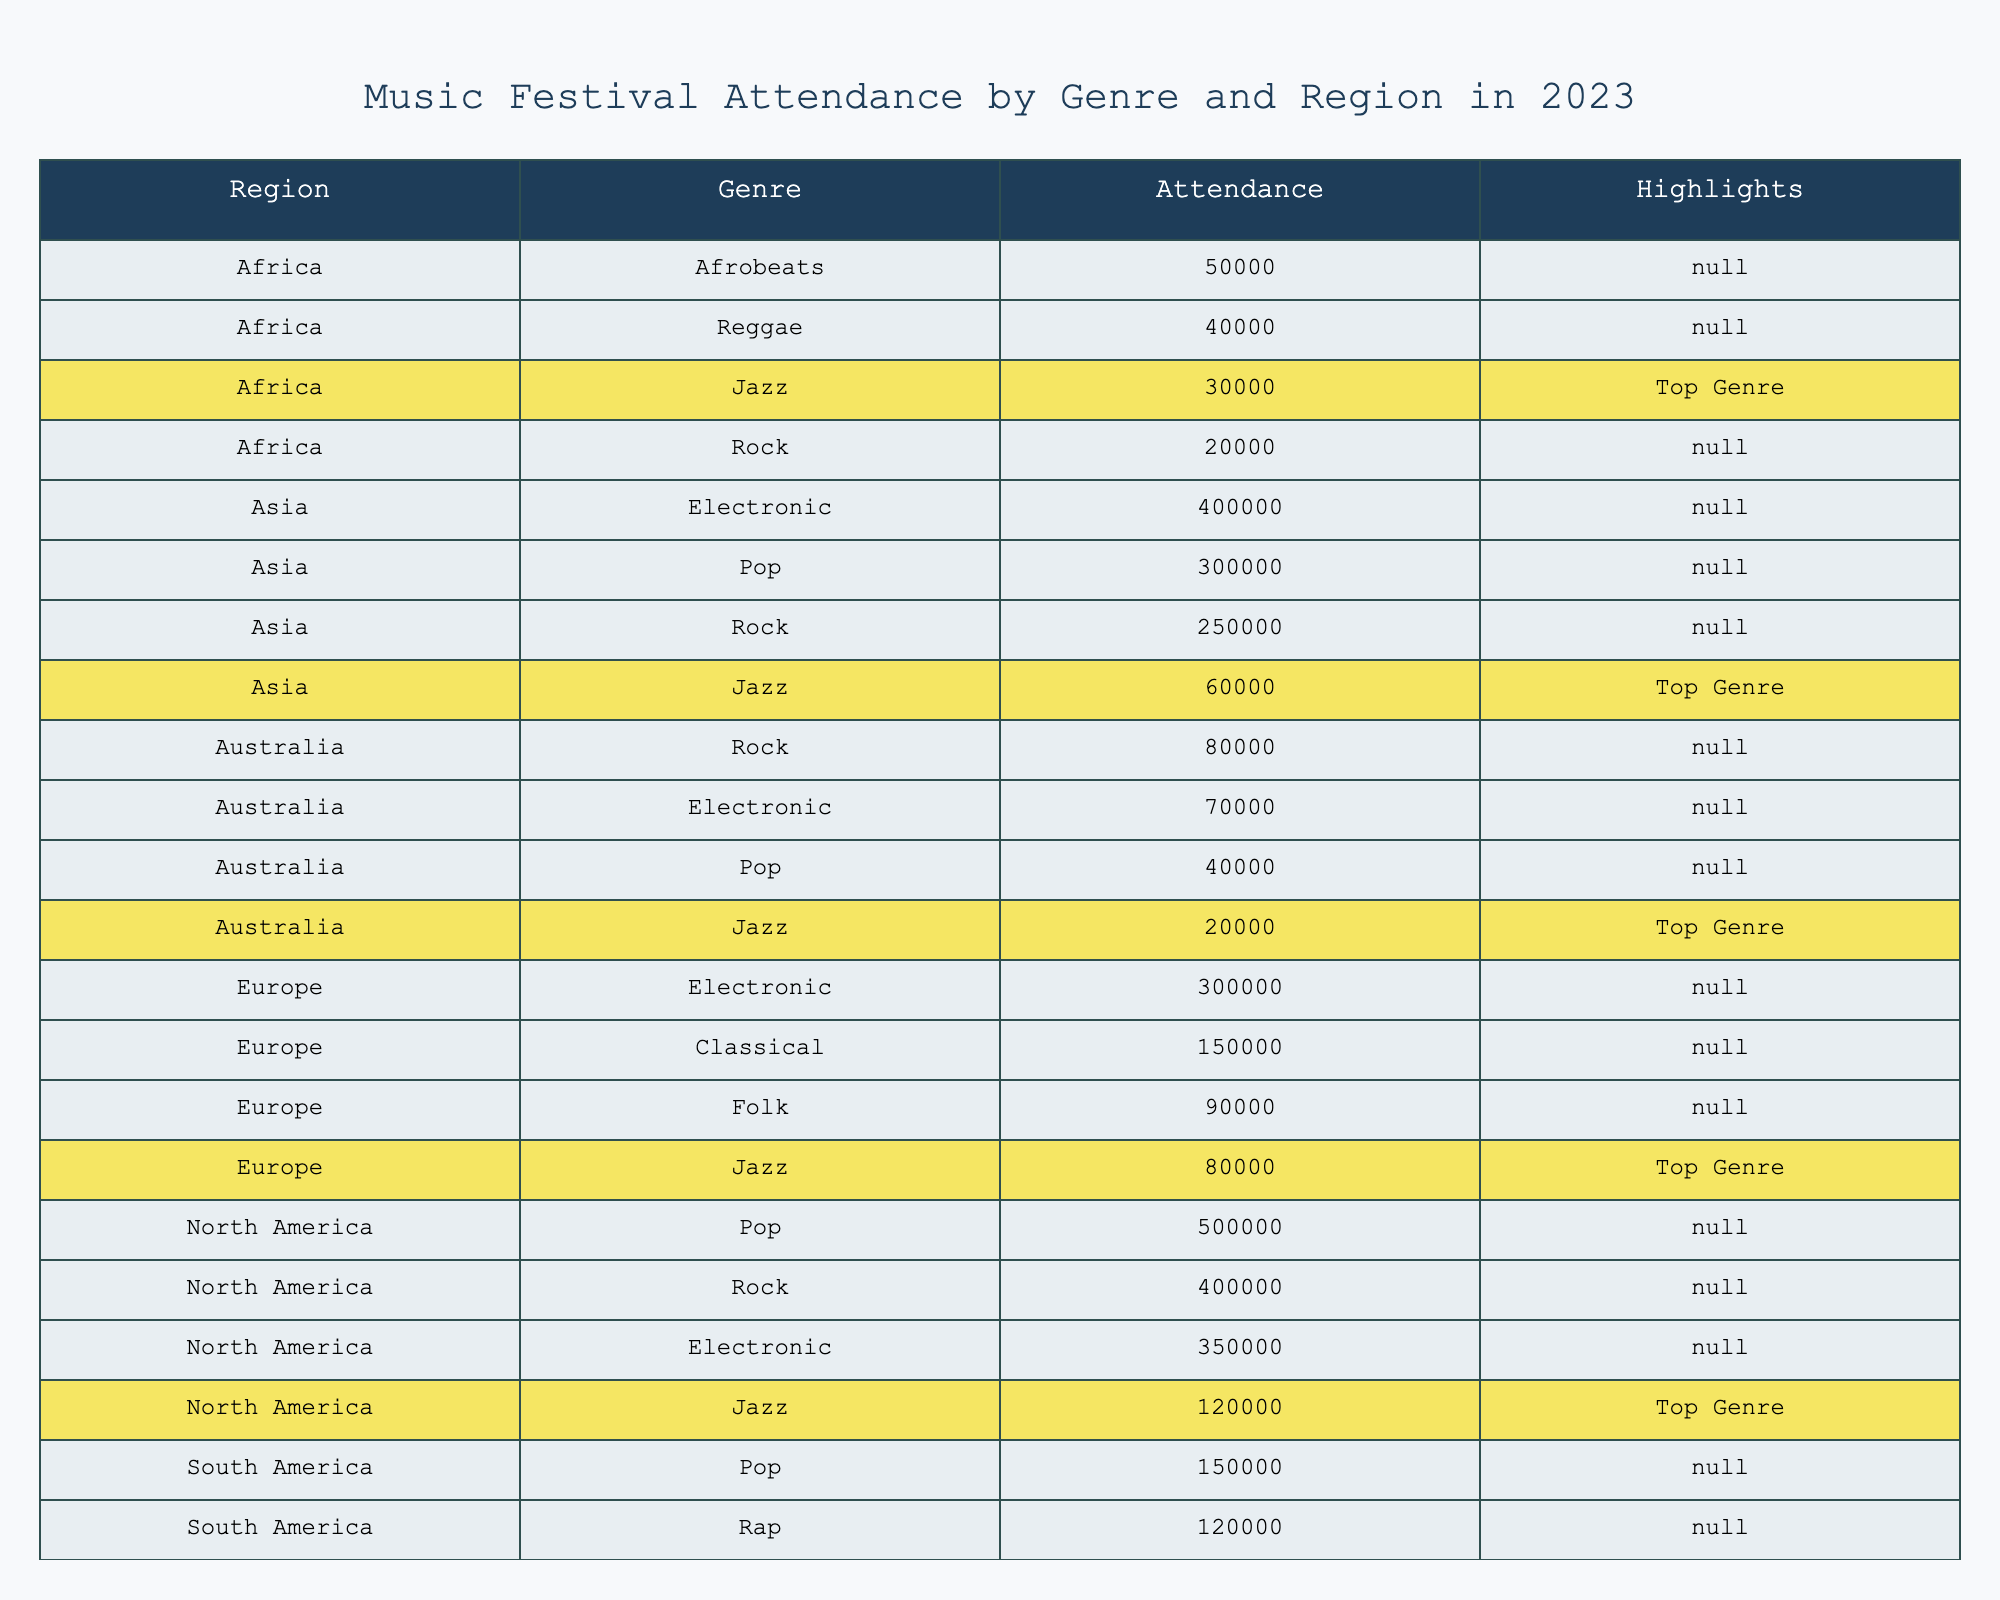What is the total attendance for Jazz across all regions? The table shows the attendance for Jazz in different regions: North America (120,000), Europe (80,000), Asia (60,000), South America (50,000), Australia (20,000), and Africa (30,000). Adding these values together gives 120,000 + 80,000 + 60,000 + 50,000 + 20,000 + 30,000 = 360,000.
Answer: 360,000 Which region had the highest attendance for Electronic music? From the table, we see that North America had 350,000 attendees for Electronic, while Europe had 300,000 and Asia had 400,000. The region with the highest attendance for Electronic music is Asia at 400,000.
Answer: Asia Is Folk music the top genre in Europe? According to the table, the top genre in Europe is Jazz, as indicated by its highlight. Folk does not have any highlight, which means Jazz is the highest genre by attendance in that region.
Answer: No What is the average attendance for Pop music across all regions? The attendance for Pop music is 500,000 (North America), 300,000 (Asia), 150,000 (South America), and 40,000 (Australia). The average is calculated as follows: (500,000 + 300,000 + 150,000 + 40,000) / 4 = 990,000 / 4 = 247,500.
Answer: 247,500 Which genre has the lowest attendance in South America? In South America, the attendance numbers are Jazz (50,000), Reggae (100,000), Pop (150,000), and Rap (120,000). The lowest among these is Jazz at 50,000.
Answer: Jazz How many total attendees were there for Rock music in North America? The table indicates that North America sees 400,000 attendees for Rock music. Thus, the total for Rock in this region is directly noted as 400,000.
Answer: 400,000 What percentage of total festival attendance did Jazz account for in Europe? The total attendance for Europe combines all genres: Jazz (80,000), Classical (150,000), Electronic (300,000), and Folk (90,000), giving 80,000 + 150,000 + 300,000 + 90,000 = 620,000. The percentage for Jazz is (80,000 / 620,000) * 100 ≈ 12.90%.
Answer: 12.90% Which region has the least total attendance for any genre, and what is that attendance? The total attendance for each region is calculated to find the minimum: North America (1,470,000), Europe (620,000), Asia (1,610,000), South America (320,000), Australia (200,000), and Africa (120,000). Thus, Australia has the least attendance, totaling 200,000.
Answer: Australia, 200,000 Are more people attending Electronic music events in Asia compared to Jazz events in the same region? The table indicates that attendance for Electronic music in Asia is 400,000, while Jazz in Asia has 60,000. Since 400,000 > 60,000, more people are attending Electronic events.
Answer: Yes In which region does the combination of Jazz and Reggae have the highest attendance, and what is that total? The total for Jazz and Reggae is calculated: North America (Jazz 120,000 + Reggae 0), Europe (Jazz 80,000 + Reggae 0), Asia (Jazz 60,000 + Reggae 0), South America (Jazz 50,000 + Reggae 100,000), Australia (Jazz 20,000 + Reggae 0), Africa (Jazz 30,000 + Reggae 40,000). The totals are: South America (150,000) and Africa (70,000). South America has the highest combined total of 150,000.
Answer: South America, 150,000 